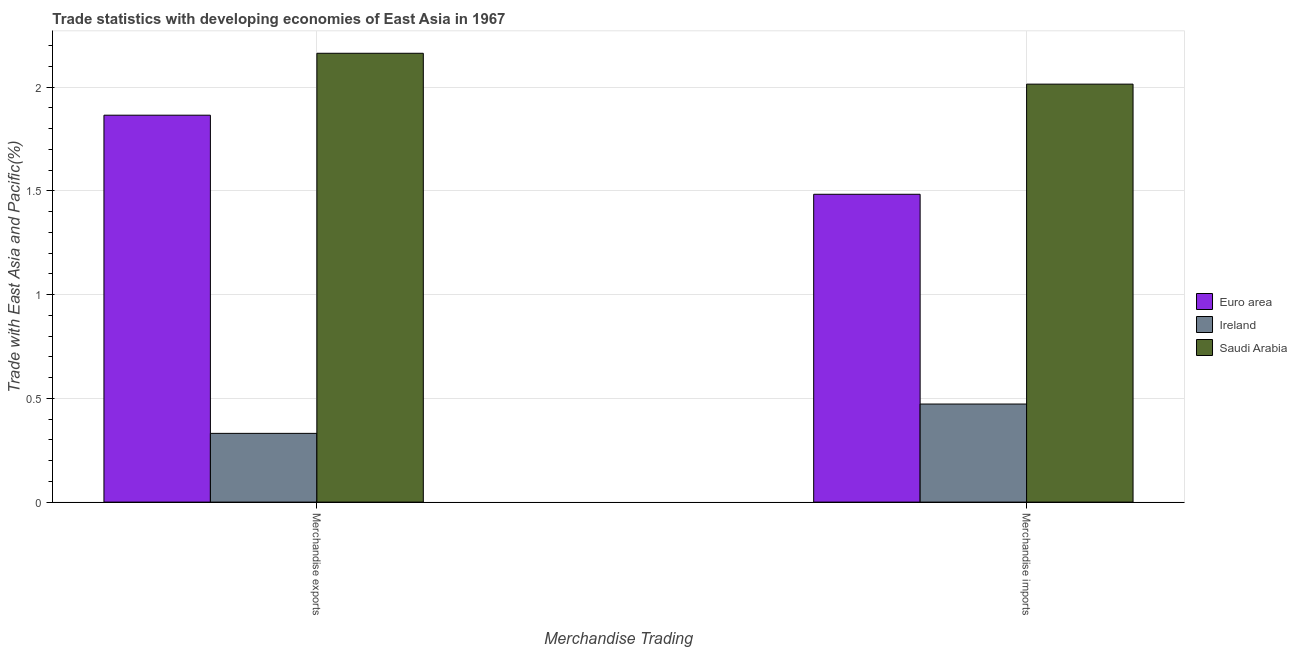Are the number of bars per tick equal to the number of legend labels?
Ensure brevity in your answer.  Yes. Are the number of bars on each tick of the X-axis equal?
Offer a very short reply. Yes. How many bars are there on the 2nd tick from the right?
Give a very brief answer. 3. What is the merchandise exports in Saudi Arabia?
Your answer should be compact. 2.16. Across all countries, what is the maximum merchandise exports?
Your answer should be compact. 2.16. Across all countries, what is the minimum merchandise exports?
Offer a terse response. 0.33. In which country was the merchandise imports maximum?
Give a very brief answer. Saudi Arabia. In which country was the merchandise imports minimum?
Give a very brief answer. Ireland. What is the total merchandise exports in the graph?
Provide a succinct answer. 4.36. What is the difference between the merchandise exports in Ireland and that in Euro area?
Your response must be concise. -1.53. What is the difference between the merchandise exports in Ireland and the merchandise imports in Saudi Arabia?
Give a very brief answer. -1.68. What is the average merchandise imports per country?
Make the answer very short. 1.32. What is the difference between the merchandise imports and merchandise exports in Ireland?
Provide a succinct answer. 0.14. What is the ratio of the merchandise imports in Ireland to that in Saudi Arabia?
Ensure brevity in your answer.  0.23. Is the merchandise exports in Euro area less than that in Saudi Arabia?
Your answer should be compact. Yes. In how many countries, is the merchandise exports greater than the average merchandise exports taken over all countries?
Provide a succinct answer. 2. What does the 3rd bar from the left in Merchandise imports represents?
Make the answer very short. Saudi Arabia. How many bars are there?
Ensure brevity in your answer.  6. Are the values on the major ticks of Y-axis written in scientific E-notation?
Offer a very short reply. No. Does the graph contain any zero values?
Keep it short and to the point. No. How are the legend labels stacked?
Ensure brevity in your answer.  Vertical. What is the title of the graph?
Make the answer very short. Trade statistics with developing economies of East Asia in 1967. What is the label or title of the X-axis?
Ensure brevity in your answer.  Merchandise Trading. What is the label or title of the Y-axis?
Provide a short and direct response. Trade with East Asia and Pacific(%). What is the Trade with East Asia and Pacific(%) in Euro area in Merchandise exports?
Give a very brief answer. 1.86. What is the Trade with East Asia and Pacific(%) of Ireland in Merchandise exports?
Ensure brevity in your answer.  0.33. What is the Trade with East Asia and Pacific(%) of Saudi Arabia in Merchandise exports?
Ensure brevity in your answer.  2.16. What is the Trade with East Asia and Pacific(%) of Euro area in Merchandise imports?
Your response must be concise. 1.48. What is the Trade with East Asia and Pacific(%) of Ireland in Merchandise imports?
Your answer should be very brief. 0.47. What is the Trade with East Asia and Pacific(%) of Saudi Arabia in Merchandise imports?
Provide a succinct answer. 2.01. Across all Merchandise Trading, what is the maximum Trade with East Asia and Pacific(%) in Euro area?
Keep it short and to the point. 1.86. Across all Merchandise Trading, what is the maximum Trade with East Asia and Pacific(%) in Ireland?
Provide a short and direct response. 0.47. Across all Merchandise Trading, what is the maximum Trade with East Asia and Pacific(%) of Saudi Arabia?
Keep it short and to the point. 2.16. Across all Merchandise Trading, what is the minimum Trade with East Asia and Pacific(%) of Euro area?
Your response must be concise. 1.48. Across all Merchandise Trading, what is the minimum Trade with East Asia and Pacific(%) of Ireland?
Offer a terse response. 0.33. Across all Merchandise Trading, what is the minimum Trade with East Asia and Pacific(%) of Saudi Arabia?
Give a very brief answer. 2.01. What is the total Trade with East Asia and Pacific(%) of Euro area in the graph?
Offer a very short reply. 3.35. What is the total Trade with East Asia and Pacific(%) of Ireland in the graph?
Ensure brevity in your answer.  0.8. What is the total Trade with East Asia and Pacific(%) of Saudi Arabia in the graph?
Offer a very short reply. 4.18. What is the difference between the Trade with East Asia and Pacific(%) in Euro area in Merchandise exports and that in Merchandise imports?
Offer a very short reply. 0.38. What is the difference between the Trade with East Asia and Pacific(%) in Ireland in Merchandise exports and that in Merchandise imports?
Your answer should be compact. -0.14. What is the difference between the Trade with East Asia and Pacific(%) in Saudi Arabia in Merchandise exports and that in Merchandise imports?
Your response must be concise. 0.15. What is the difference between the Trade with East Asia and Pacific(%) in Euro area in Merchandise exports and the Trade with East Asia and Pacific(%) in Ireland in Merchandise imports?
Make the answer very short. 1.39. What is the difference between the Trade with East Asia and Pacific(%) in Euro area in Merchandise exports and the Trade with East Asia and Pacific(%) in Saudi Arabia in Merchandise imports?
Offer a terse response. -0.15. What is the difference between the Trade with East Asia and Pacific(%) in Ireland in Merchandise exports and the Trade with East Asia and Pacific(%) in Saudi Arabia in Merchandise imports?
Keep it short and to the point. -1.68. What is the average Trade with East Asia and Pacific(%) of Euro area per Merchandise Trading?
Provide a short and direct response. 1.67. What is the average Trade with East Asia and Pacific(%) in Ireland per Merchandise Trading?
Your answer should be very brief. 0.4. What is the average Trade with East Asia and Pacific(%) in Saudi Arabia per Merchandise Trading?
Your response must be concise. 2.09. What is the difference between the Trade with East Asia and Pacific(%) of Euro area and Trade with East Asia and Pacific(%) of Ireland in Merchandise exports?
Provide a short and direct response. 1.53. What is the difference between the Trade with East Asia and Pacific(%) of Euro area and Trade with East Asia and Pacific(%) of Saudi Arabia in Merchandise exports?
Offer a very short reply. -0.3. What is the difference between the Trade with East Asia and Pacific(%) of Ireland and Trade with East Asia and Pacific(%) of Saudi Arabia in Merchandise exports?
Ensure brevity in your answer.  -1.83. What is the difference between the Trade with East Asia and Pacific(%) of Euro area and Trade with East Asia and Pacific(%) of Ireland in Merchandise imports?
Your answer should be compact. 1.01. What is the difference between the Trade with East Asia and Pacific(%) of Euro area and Trade with East Asia and Pacific(%) of Saudi Arabia in Merchandise imports?
Make the answer very short. -0.53. What is the difference between the Trade with East Asia and Pacific(%) of Ireland and Trade with East Asia and Pacific(%) of Saudi Arabia in Merchandise imports?
Make the answer very short. -1.54. What is the ratio of the Trade with East Asia and Pacific(%) of Euro area in Merchandise exports to that in Merchandise imports?
Keep it short and to the point. 1.26. What is the ratio of the Trade with East Asia and Pacific(%) of Ireland in Merchandise exports to that in Merchandise imports?
Offer a terse response. 0.7. What is the ratio of the Trade with East Asia and Pacific(%) in Saudi Arabia in Merchandise exports to that in Merchandise imports?
Provide a succinct answer. 1.07. What is the difference between the highest and the second highest Trade with East Asia and Pacific(%) in Euro area?
Provide a succinct answer. 0.38. What is the difference between the highest and the second highest Trade with East Asia and Pacific(%) of Ireland?
Your response must be concise. 0.14. What is the difference between the highest and the second highest Trade with East Asia and Pacific(%) of Saudi Arabia?
Your answer should be very brief. 0.15. What is the difference between the highest and the lowest Trade with East Asia and Pacific(%) of Euro area?
Provide a short and direct response. 0.38. What is the difference between the highest and the lowest Trade with East Asia and Pacific(%) of Ireland?
Provide a short and direct response. 0.14. What is the difference between the highest and the lowest Trade with East Asia and Pacific(%) of Saudi Arabia?
Provide a succinct answer. 0.15. 